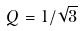Convert formula to latex. <formula><loc_0><loc_0><loc_500><loc_500>Q = 1 / \sqrt { 3 }</formula> 